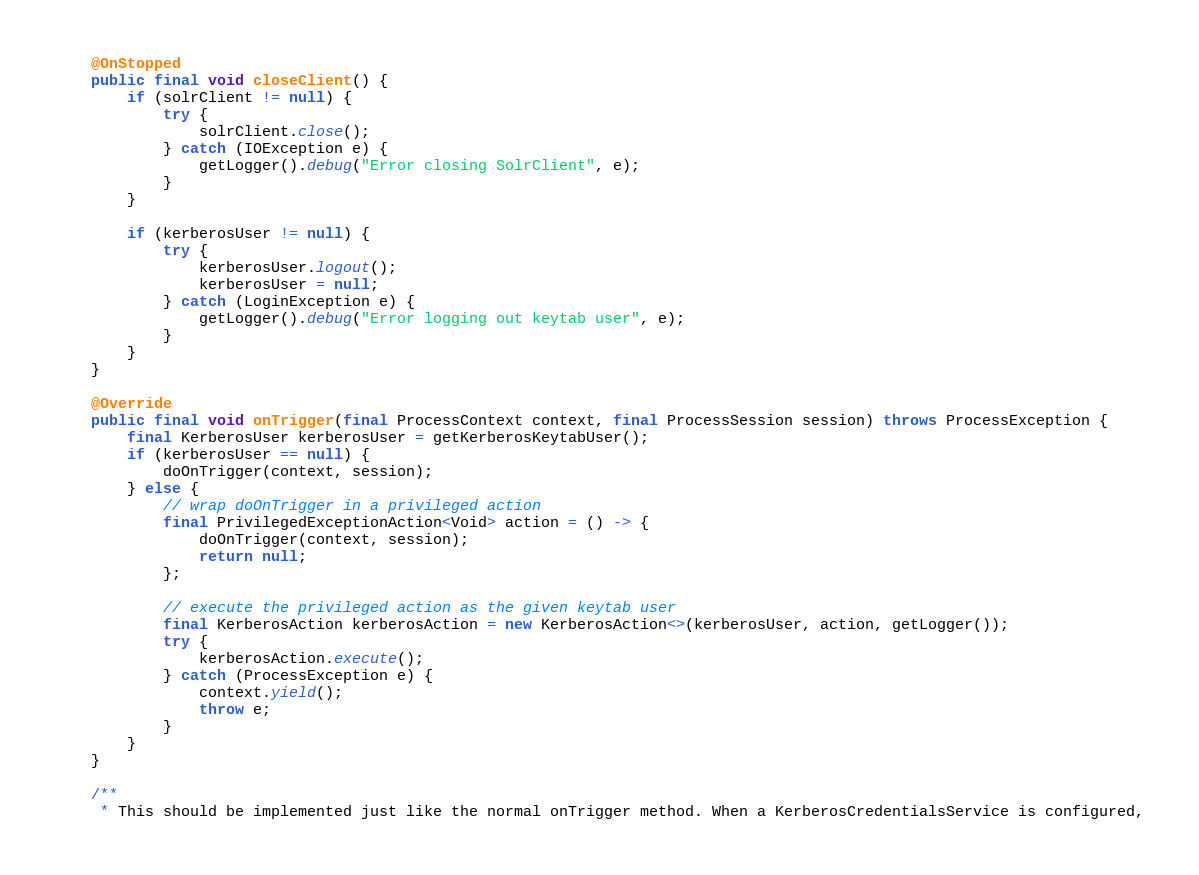<code> <loc_0><loc_0><loc_500><loc_500><_Java_>    @OnStopped
    public final void closeClient() {
        if (solrClient != null) {
            try {
                solrClient.close();
            } catch (IOException e) {
                getLogger().debug("Error closing SolrClient", e);
            }
        }

        if (kerberosUser != null) {
            try {
                kerberosUser.logout();
                kerberosUser = null;
            } catch (LoginException e) {
                getLogger().debug("Error logging out keytab user", e);
            }
        }
    }

    @Override
    public final void onTrigger(final ProcessContext context, final ProcessSession session) throws ProcessException {
        final KerberosUser kerberosUser = getKerberosKeytabUser();
        if (kerberosUser == null) {
            doOnTrigger(context, session);
        } else {
            // wrap doOnTrigger in a privileged action
            final PrivilegedExceptionAction<Void> action = () -> {
                doOnTrigger(context, session);
                return null;
            };

            // execute the privileged action as the given keytab user
            final KerberosAction kerberosAction = new KerberosAction<>(kerberosUser, action, getLogger());
            try {
                kerberosAction.execute();
            } catch (ProcessException e) {
                context.yield();
                throw e;
            }
        }
    }

    /**
     * This should be implemented just like the normal onTrigger method. When a KerberosCredentialsService is configured,</code> 